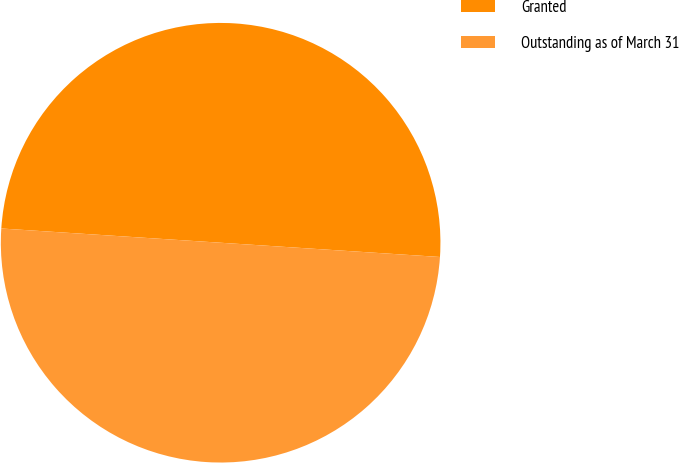Convert chart. <chart><loc_0><loc_0><loc_500><loc_500><pie_chart><fcel>Granted<fcel>Outstanding as of March 31<nl><fcel>50.0%<fcel>50.0%<nl></chart> 